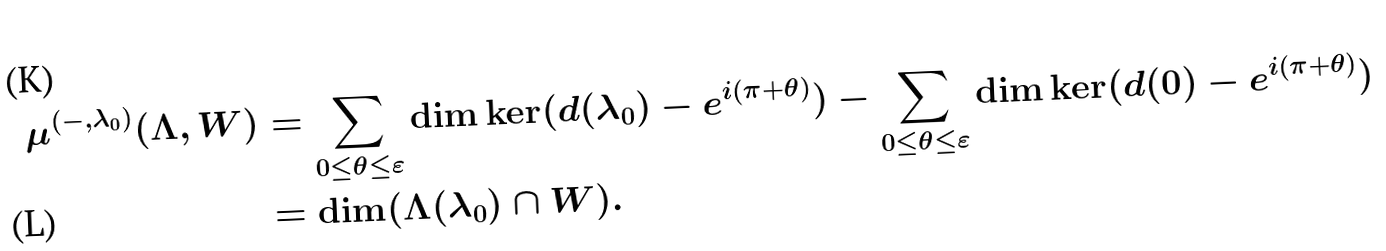<formula> <loc_0><loc_0><loc_500><loc_500>\mu ^ { ( - , \lambda _ { 0 } ) } ( \Lambda , W ) & = \sum _ { 0 \leq \theta \leq \varepsilon } \dim \ker ( d ( \lambda _ { 0 } ) - e ^ { i ( \pi + \theta ) } ) - \sum _ { 0 \leq \theta \leq \varepsilon } \dim \ker ( d ( 0 ) - e ^ { i ( \pi + \theta ) } ) \\ & = \dim ( \Lambda ( \lambda _ { 0 } ) \cap W ) .</formula> 